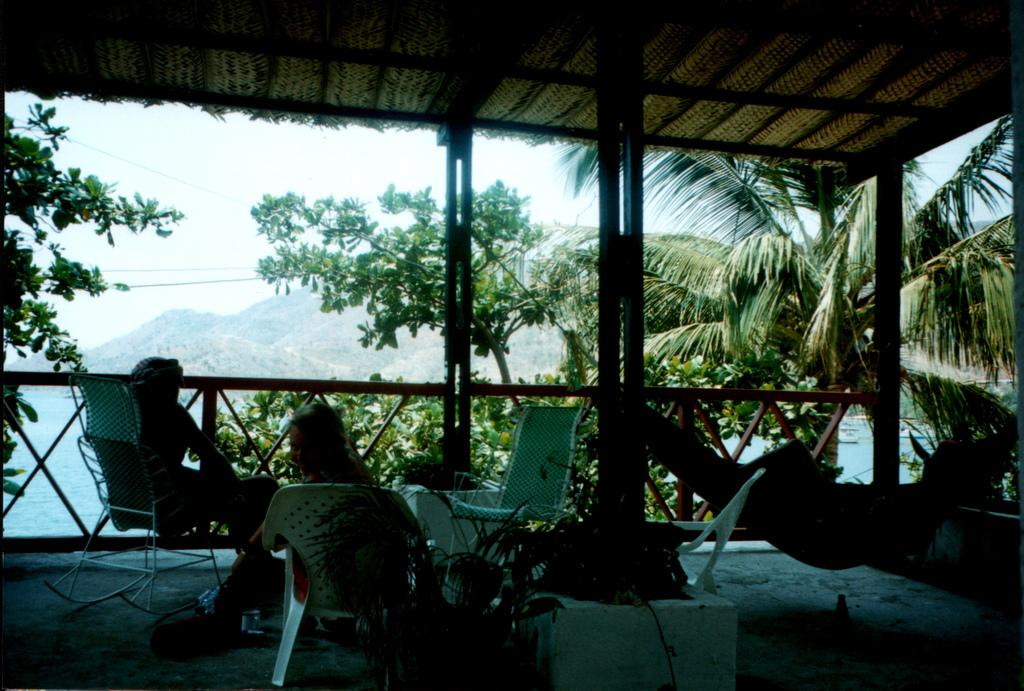What type of vegetation can be seen in the image? There are trees in the image. What are the two persons in the image doing? The two persons are sitting on chairs. Where are the chairs located in the image? The chairs are in the middle of the image. What can be seen in the background of the image? There are hills and the sky visible in the background of the image. What type of bread is being crushed by the toothbrush in the image? There is no bread or toothbrush present in the image. How many toothbrushes are visible in the image? There are no toothbrushes present in the image. 